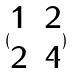<formula> <loc_0><loc_0><loc_500><loc_500>( \begin{matrix} 1 & 2 \\ 2 & 4 \end{matrix} )</formula> 